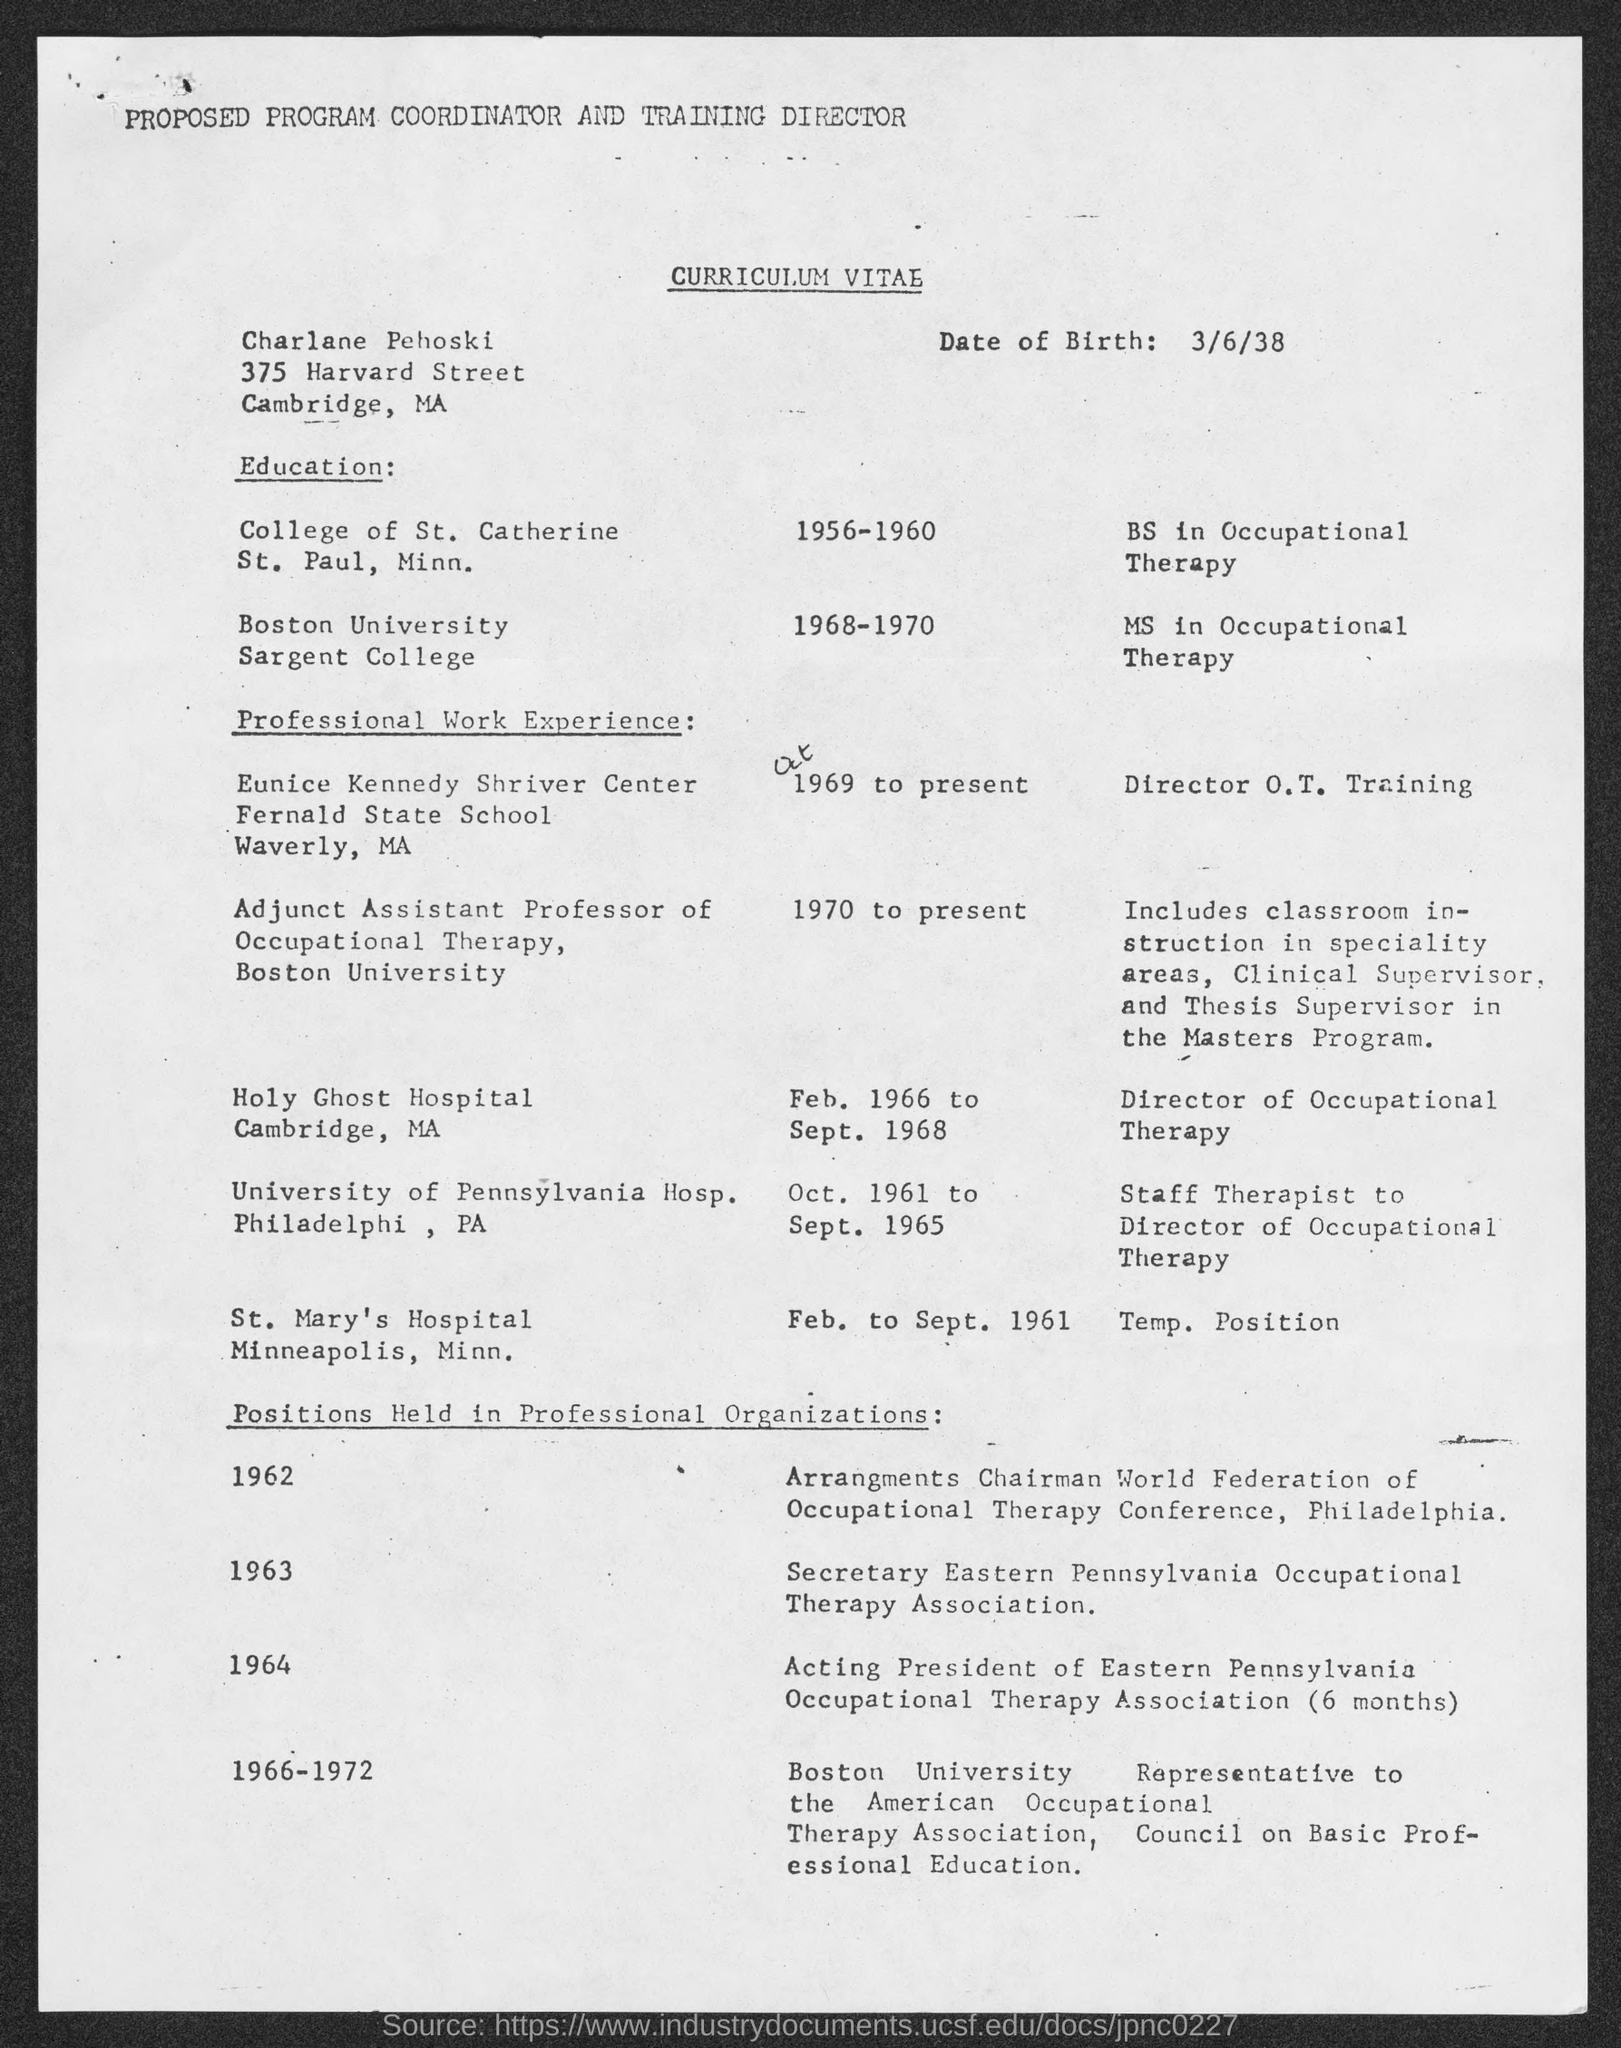What is the Title of the document?
Offer a very short reply. CURRICULUM VITAE. What is the date of birth?
Provide a succinct answer. 3/6/38. 